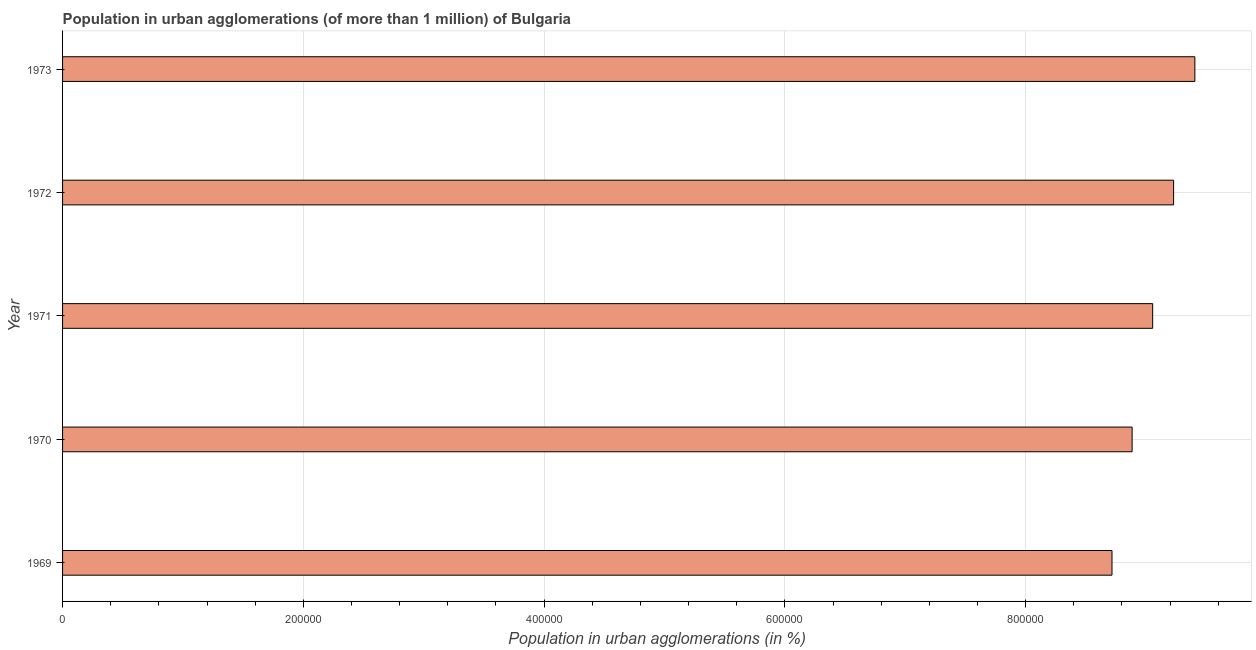Does the graph contain any zero values?
Offer a terse response. No. What is the title of the graph?
Your answer should be very brief. Population in urban agglomerations (of more than 1 million) of Bulgaria. What is the label or title of the X-axis?
Ensure brevity in your answer.  Population in urban agglomerations (in %). What is the label or title of the Y-axis?
Provide a short and direct response. Year. What is the population in urban agglomerations in 1969?
Offer a terse response. 8.72e+05. Across all years, what is the maximum population in urban agglomerations?
Ensure brevity in your answer.  9.41e+05. Across all years, what is the minimum population in urban agglomerations?
Provide a succinct answer. 8.72e+05. In which year was the population in urban agglomerations maximum?
Ensure brevity in your answer.  1973. In which year was the population in urban agglomerations minimum?
Offer a very short reply. 1969. What is the sum of the population in urban agglomerations?
Offer a terse response. 4.53e+06. What is the difference between the population in urban agglomerations in 1969 and 1970?
Offer a terse response. -1.67e+04. What is the average population in urban agglomerations per year?
Give a very brief answer. 9.06e+05. What is the median population in urban agglomerations?
Your answer should be very brief. 9.05e+05. In how many years, is the population in urban agglomerations greater than 920000 %?
Your response must be concise. 2. Do a majority of the years between 1969 and 1972 (inclusive) have population in urban agglomerations greater than 920000 %?
Your answer should be compact. No. What is the ratio of the population in urban agglomerations in 1970 to that in 1973?
Give a very brief answer. 0.94. Is the population in urban agglomerations in 1969 less than that in 1973?
Your answer should be compact. Yes. Is the difference between the population in urban agglomerations in 1969 and 1970 greater than the difference between any two years?
Provide a short and direct response. No. What is the difference between the highest and the second highest population in urban agglomerations?
Provide a short and direct response. 1.77e+04. Is the sum of the population in urban agglomerations in 1971 and 1972 greater than the maximum population in urban agglomerations across all years?
Your answer should be compact. Yes. What is the difference between the highest and the lowest population in urban agglomerations?
Provide a succinct answer. 6.88e+04. In how many years, is the population in urban agglomerations greater than the average population in urban agglomerations taken over all years?
Make the answer very short. 2. Are all the bars in the graph horizontal?
Offer a terse response. Yes. Are the values on the major ticks of X-axis written in scientific E-notation?
Your response must be concise. No. What is the Population in urban agglomerations (in %) of 1969?
Your answer should be compact. 8.72e+05. What is the Population in urban agglomerations (in %) in 1970?
Provide a short and direct response. 8.88e+05. What is the Population in urban agglomerations (in %) of 1971?
Your answer should be very brief. 9.05e+05. What is the Population in urban agglomerations (in %) of 1972?
Offer a very short reply. 9.23e+05. What is the Population in urban agglomerations (in %) of 1973?
Offer a very short reply. 9.41e+05. What is the difference between the Population in urban agglomerations (in %) in 1969 and 1970?
Offer a very short reply. -1.67e+04. What is the difference between the Population in urban agglomerations (in %) in 1969 and 1971?
Provide a short and direct response. -3.38e+04. What is the difference between the Population in urban agglomerations (in %) in 1969 and 1972?
Your response must be concise. -5.12e+04. What is the difference between the Population in urban agglomerations (in %) in 1969 and 1973?
Ensure brevity in your answer.  -6.88e+04. What is the difference between the Population in urban agglomerations (in %) in 1970 and 1971?
Ensure brevity in your answer.  -1.70e+04. What is the difference between the Population in urban agglomerations (in %) in 1970 and 1972?
Your response must be concise. -3.44e+04. What is the difference between the Population in urban agglomerations (in %) in 1970 and 1973?
Offer a terse response. -5.21e+04. What is the difference between the Population in urban agglomerations (in %) in 1971 and 1972?
Your answer should be very brief. -1.74e+04. What is the difference between the Population in urban agglomerations (in %) in 1971 and 1973?
Offer a terse response. -3.51e+04. What is the difference between the Population in urban agglomerations (in %) in 1972 and 1973?
Provide a succinct answer. -1.77e+04. What is the ratio of the Population in urban agglomerations (in %) in 1969 to that in 1970?
Your response must be concise. 0.98. What is the ratio of the Population in urban agglomerations (in %) in 1969 to that in 1971?
Your response must be concise. 0.96. What is the ratio of the Population in urban agglomerations (in %) in 1969 to that in 1972?
Your answer should be compact. 0.94. What is the ratio of the Population in urban agglomerations (in %) in 1969 to that in 1973?
Make the answer very short. 0.93. What is the ratio of the Population in urban agglomerations (in %) in 1970 to that in 1973?
Offer a terse response. 0.94. What is the ratio of the Population in urban agglomerations (in %) in 1972 to that in 1973?
Give a very brief answer. 0.98. 